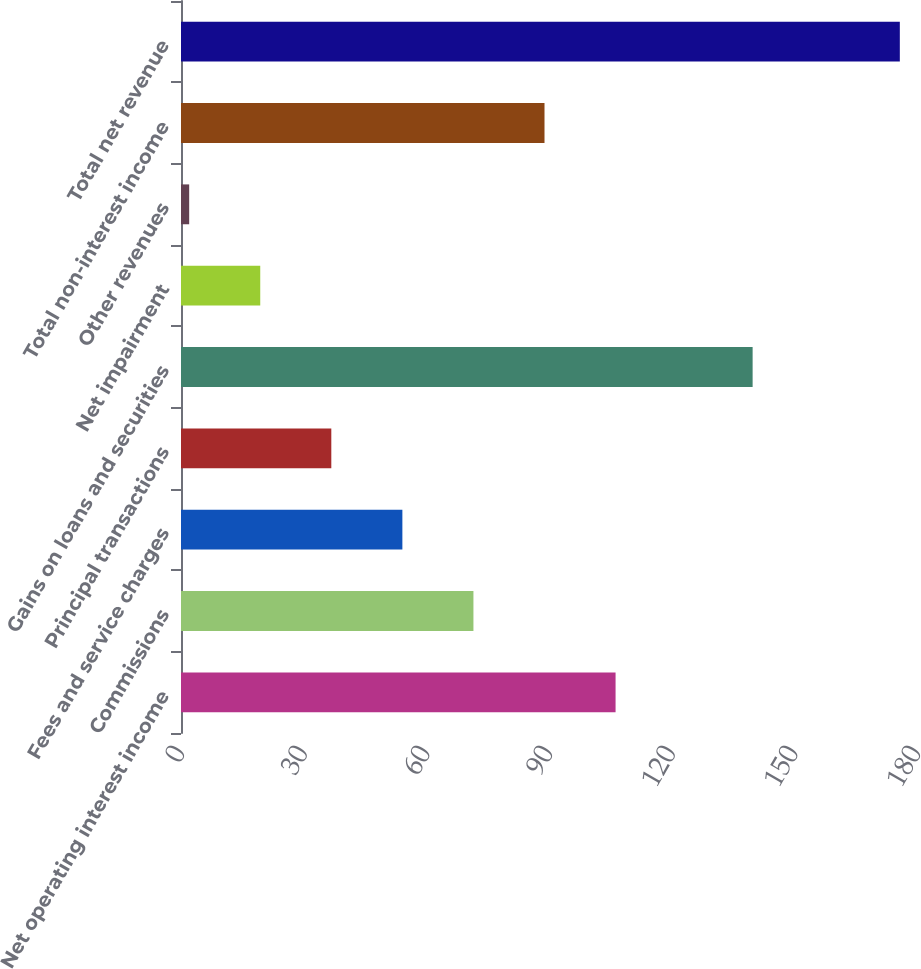<chart> <loc_0><loc_0><loc_500><loc_500><bar_chart><fcel>Net operating interest income<fcel>Commissions<fcel>Fees and service charges<fcel>Principal transactions<fcel>Gains on loans and securities<fcel>Net impairment<fcel>Other revenues<fcel>Total non-interest income<fcel>Total net revenue<nl><fcel>106.28<fcel>71.52<fcel>54.14<fcel>36.76<fcel>139.8<fcel>19.38<fcel>2<fcel>88.9<fcel>175.8<nl></chart> 